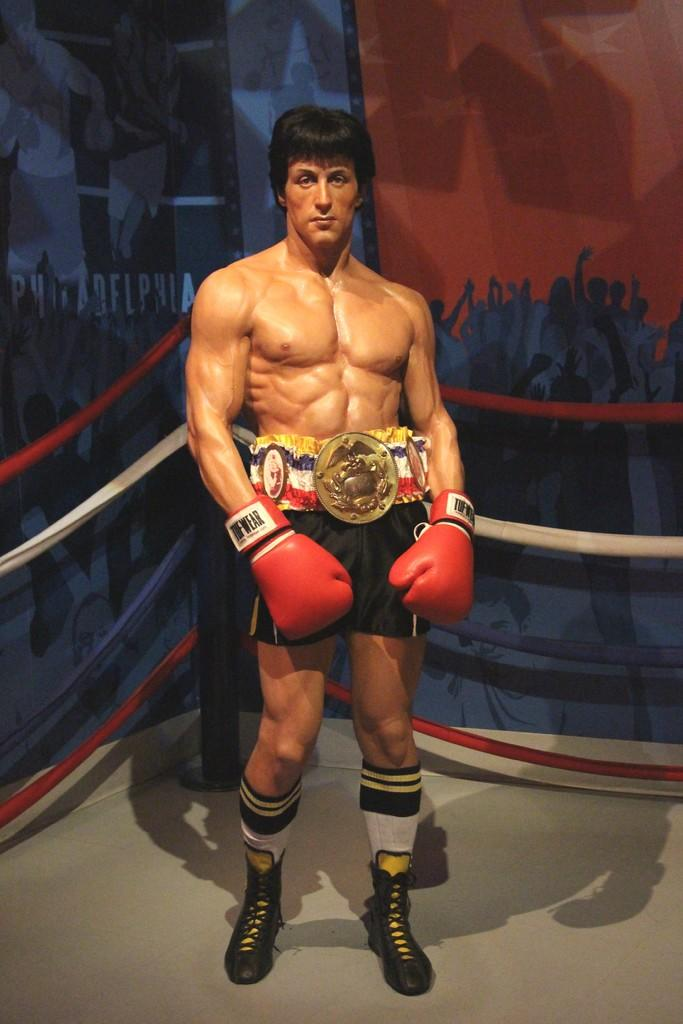What is the main subject of the image? There is a man standing in the center of the image. What is behind the man? There is a railing behind the man. What can be seen in the background of the image? In the background, there are boards with text and images on them. What type of wind can be seen blowing through the text on the boards in the image? There is no wind present in the image, and the text on the boards is not affected by any wind. 